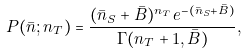Convert formula to latex. <formula><loc_0><loc_0><loc_500><loc_500>P ( \bar { n } ; n _ { T } ) = \frac { ( \bar { n } _ { S } + \bar { B } ) ^ { n _ { T } } e ^ { - ( \bar { n } _ { S } + \bar { B } ) } } { \Gamma ( n _ { T } + 1 , \bar { B } ) } ,</formula> 